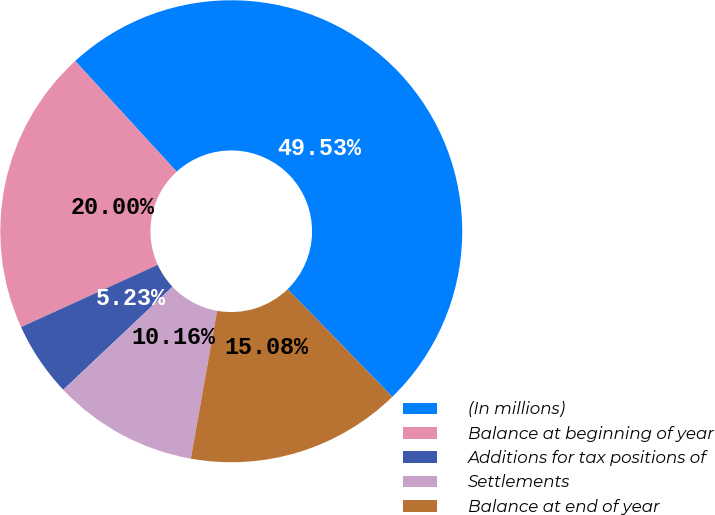<chart> <loc_0><loc_0><loc_500><loc_500><pie_chart><fcel>(In millions)<fcel>Balance at beginning of year<fcel>Additions for tax positions of<fcel>Settlements<fcel>Balance at end of year<nl><fcel>49.53%<fcel>20.0%<fcel>5.23%<fcel>10.16%<fcel>15.08%<nl></chart> 